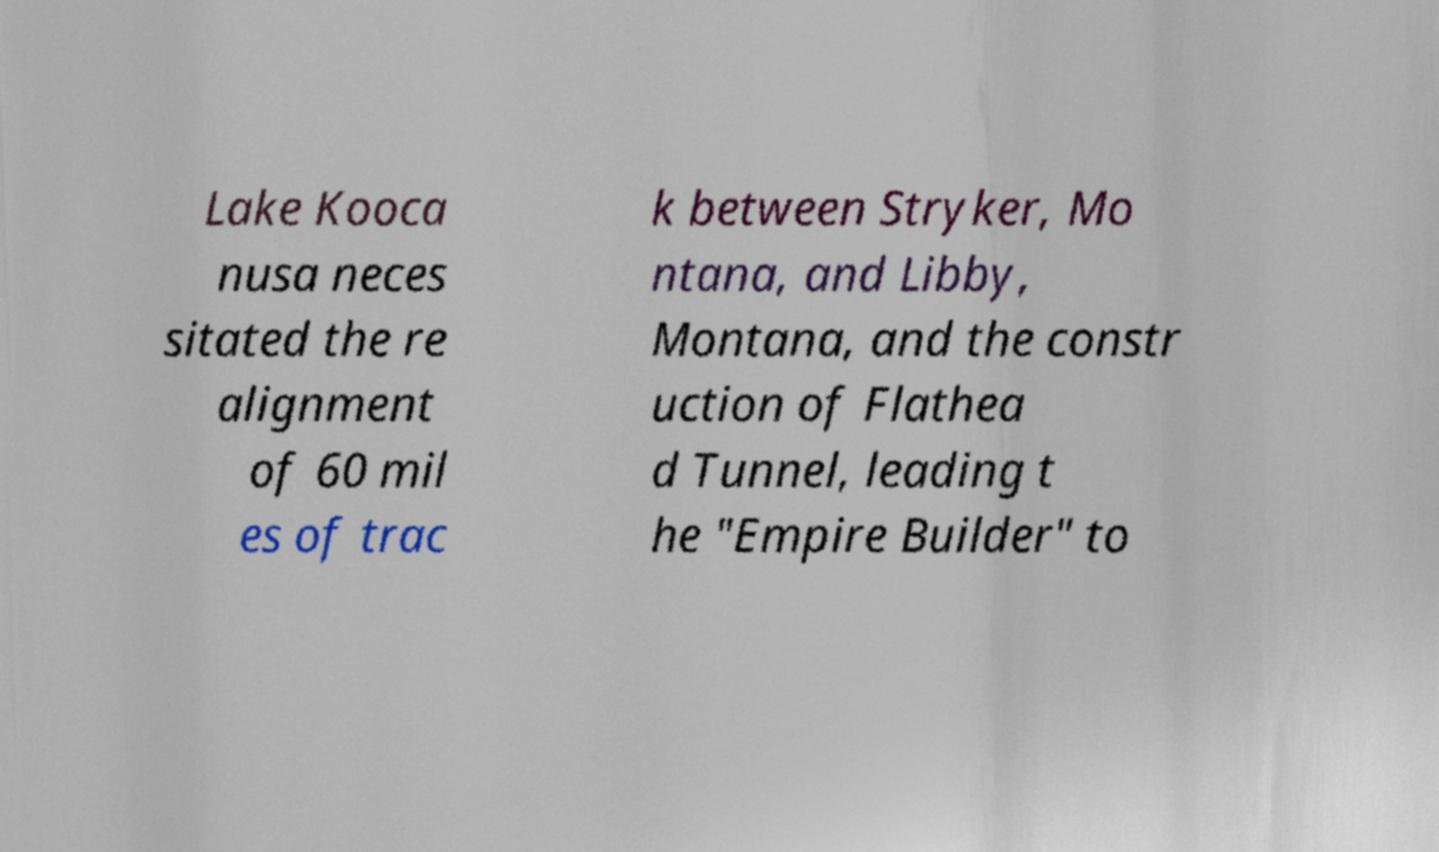Please read and relay the text visible in this image. What does it say? Lake Kooca nusa neces sitated the re alignment of 60 mil es of trac k between Stryker, Mo ntana, and Libby, Montana, and the constr uction of Flathea d Tunnel, leading t he "Empire Builder" to 